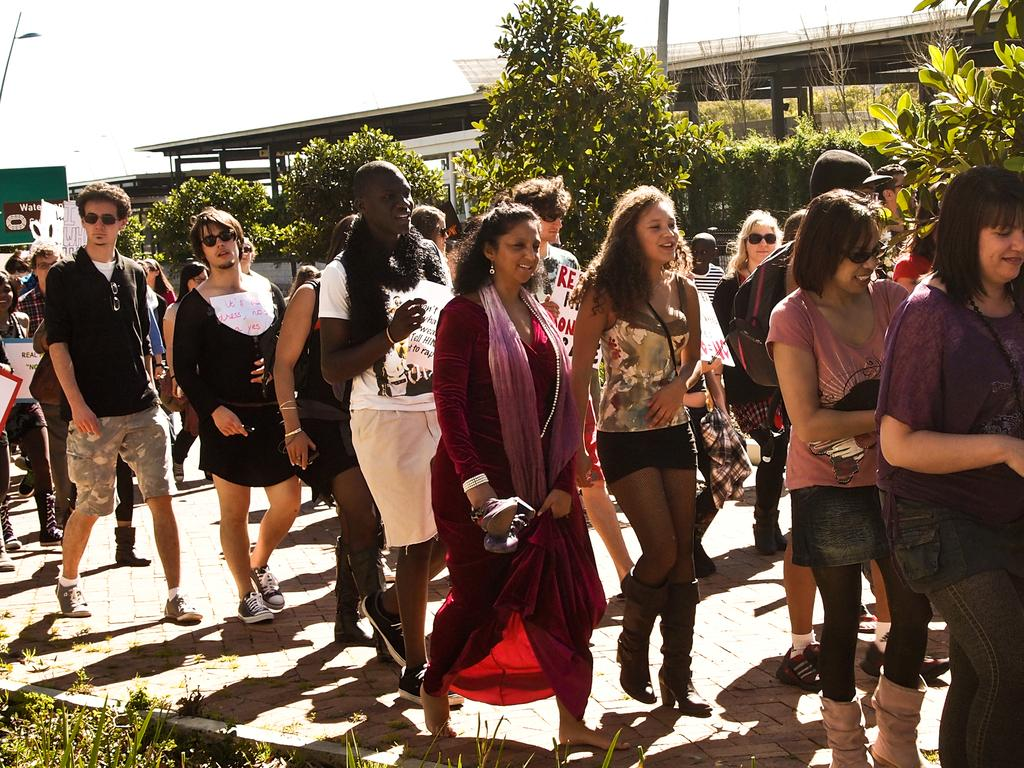How many people are in the image? There is a group of people in the image. What are the people in the image doing? The people are walking. What type of surface are the people walking on? There is grass at the bottom of the image, which suggests they are walking on grass. What can be seen in the background of the image? There are buildings, trees, poles, and boards in the background of the image. What architectural feature is present in the image? There is a walkway in the image. Can you tell me what the people are arguing about in the image? There is no indication of an argument in the image; the people are simply walking. Is there a zebra present in the image? No, there is no zebra present in the image. 